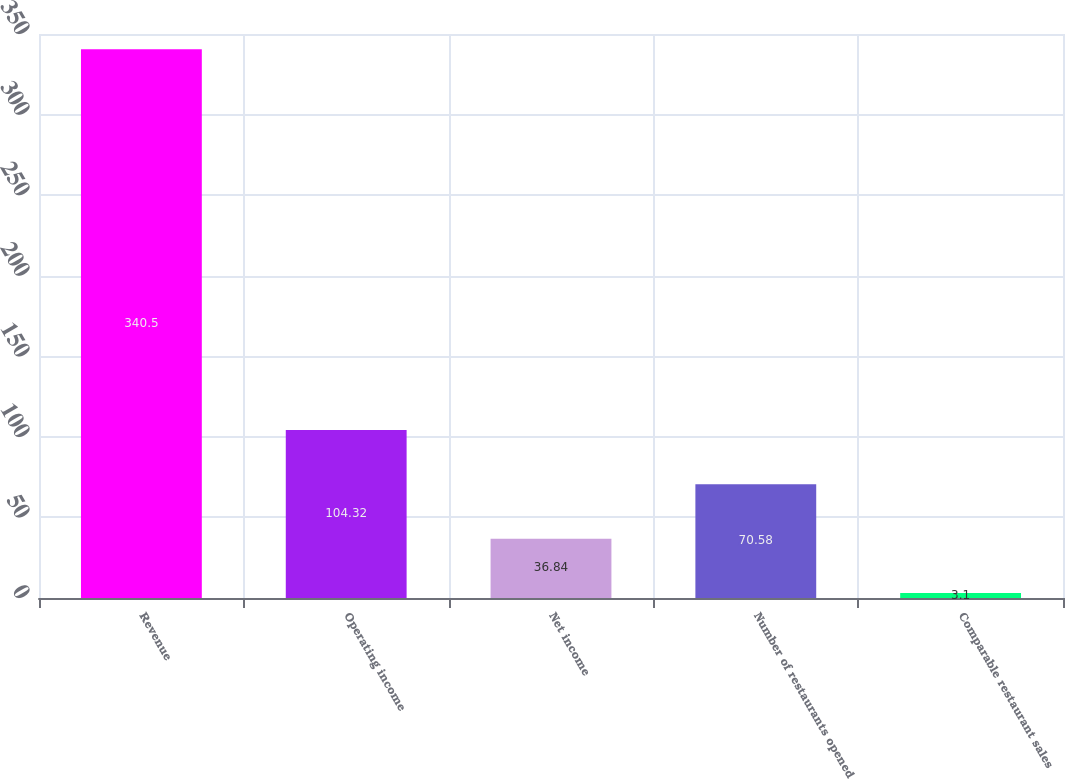<chart> <loc_0><loc_0><loc_500><loc_500><bar_chart><fcel>Revenue<fcel>Operating income<fcel>Net income<fcel>Number of restaurants opened<fcel>Comparable restaurant sales<nl><fcel>340.5<fcel>104.32<fcel>36.84<fcel>70.58<fcel>3.1<nl></chart> 